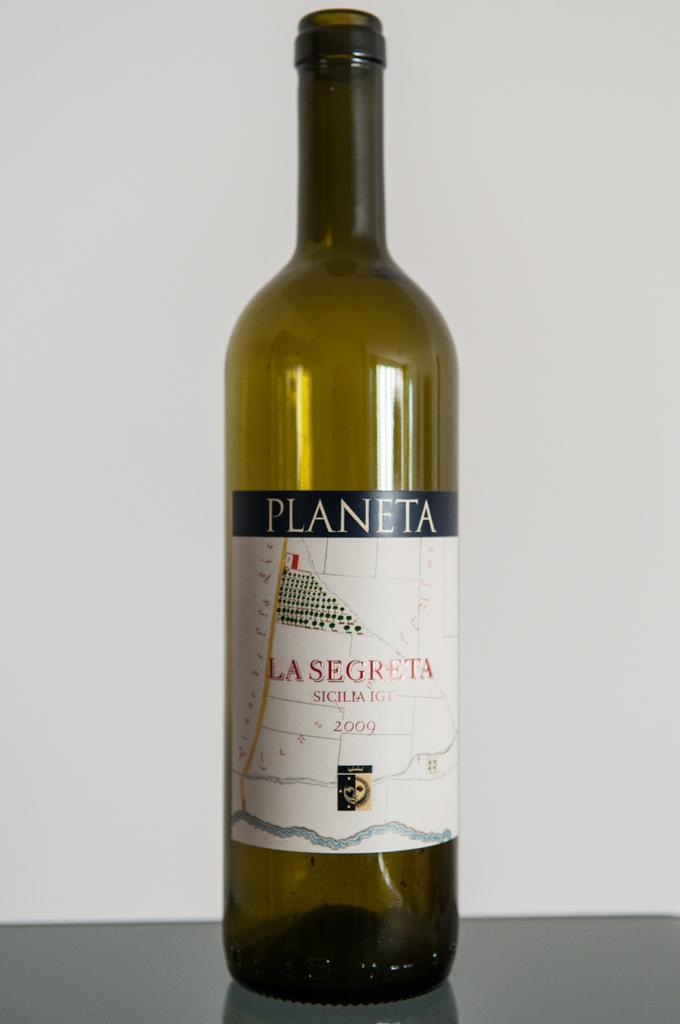What year was this wine bottled in?
Provide a short and direct response. 2009. 